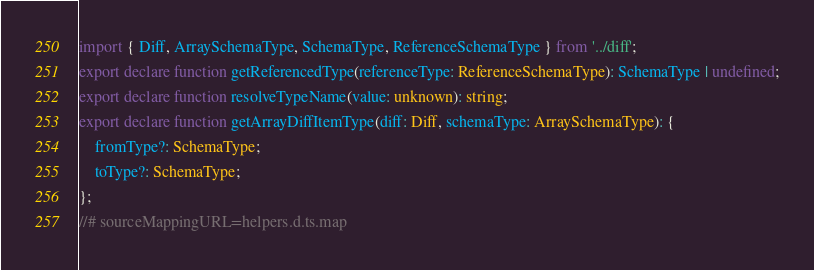Convert code to text. <code><loc_0><loc_0><loc_500><loc_500><_TypeScript_>import { Diff, ArraySchemaType, SchemaType, ReferenceSchemaType } from '../diff';
export declare function getReferencedType(referenceType: ReferenceSchemaType): SchemaType | undefined;
export declare function resolveTypeName(value: unknown): string;
export declare function getArrayDiffItemType(diff: Diff, schemaType: ArraySchemaType): {
    fromType?: SchemaType;
    toType?: SchemaType;
};
//# sourceMappingURL=helpers.d.ts.map</code> 